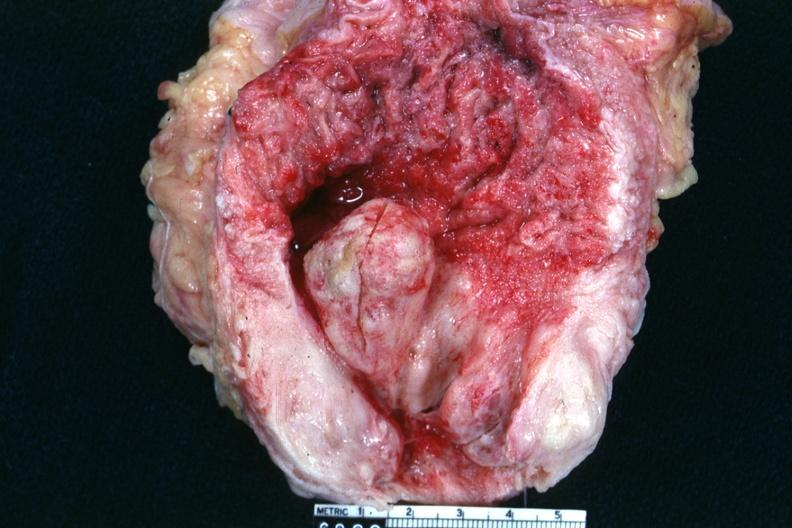s hyperplasia present?
Answer the question using a single word or phrase. Yes 